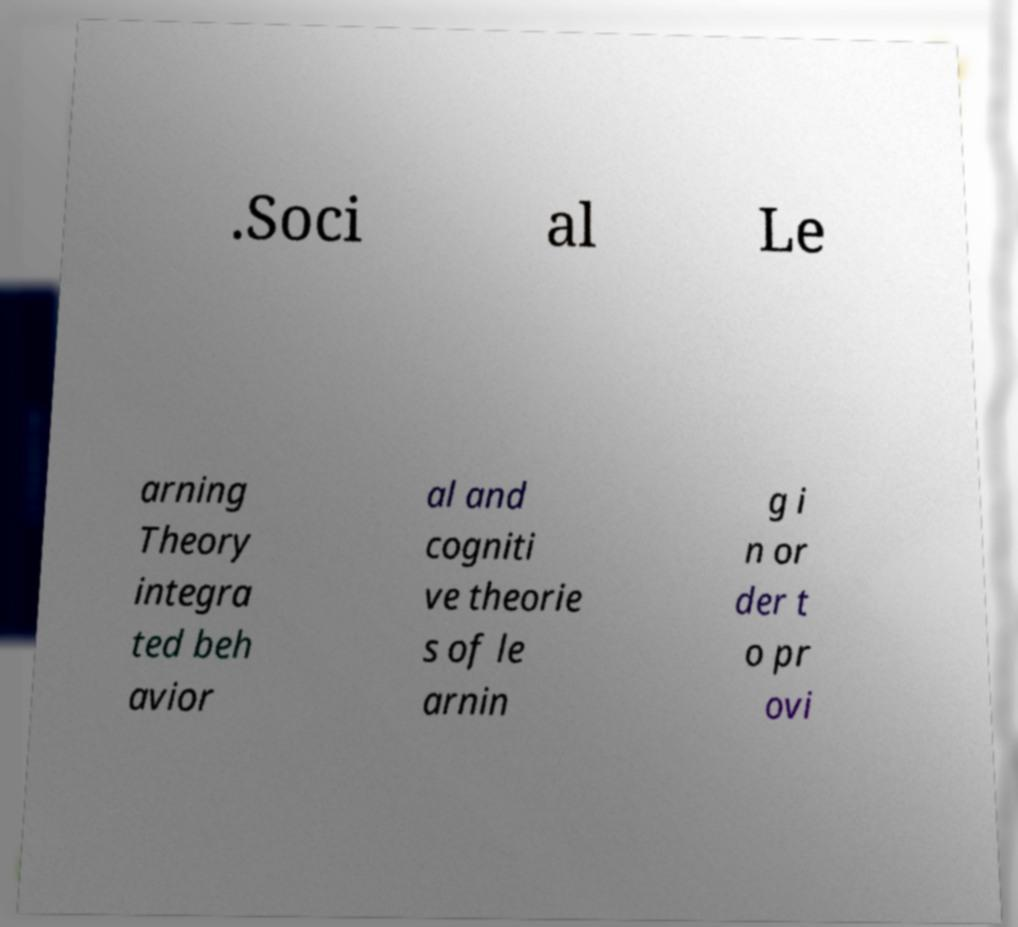For documentation purposes, I need the text within this image transcribed. Could you provide that? .Soci al Le arning Theory integra ted beh avior al and cogniti ve theorie s of le arnin g i n or der t o pr ovi 